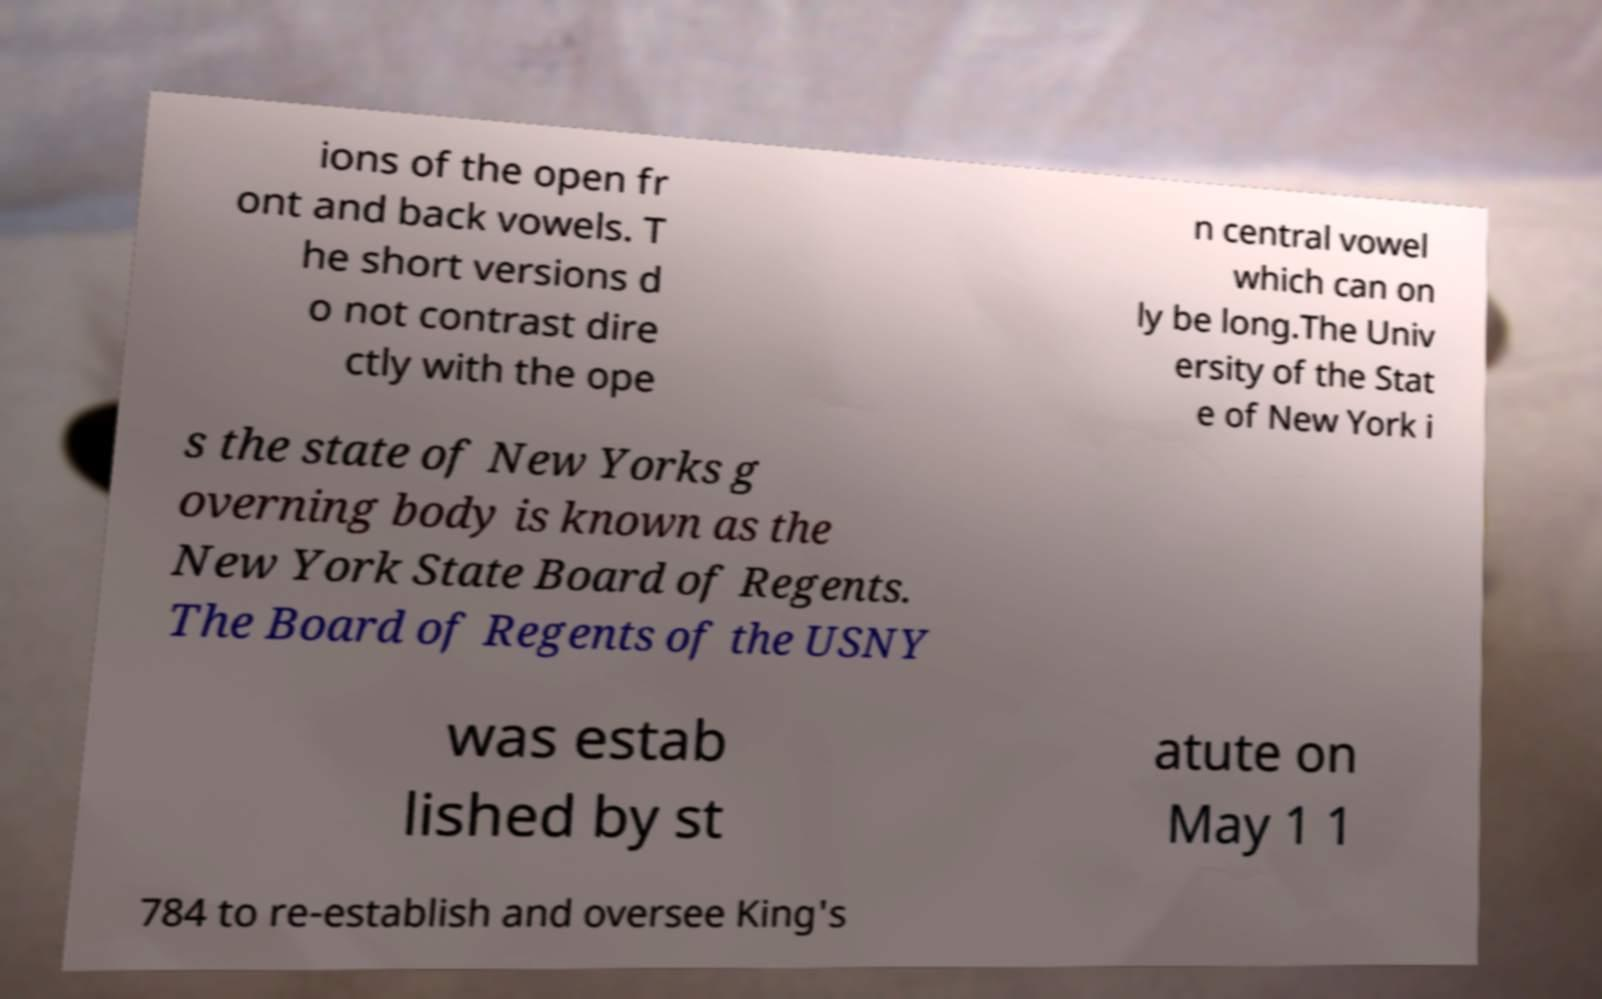For documentation purposes, I need the text within this image transcribed. Could you provide that? ions of the open fr ont and back vowels. T he short versions d o not contrast dire ctly with the ope n central vowel which can on ly be long.The Univ ersity of the Stat e of New York i s the state of New Yorks g overning body is known as the New York State Board of Regents. The Board of Regents of the USNY was estab lished by st atute on May 1 1 784 to re-establish and oversee King's 